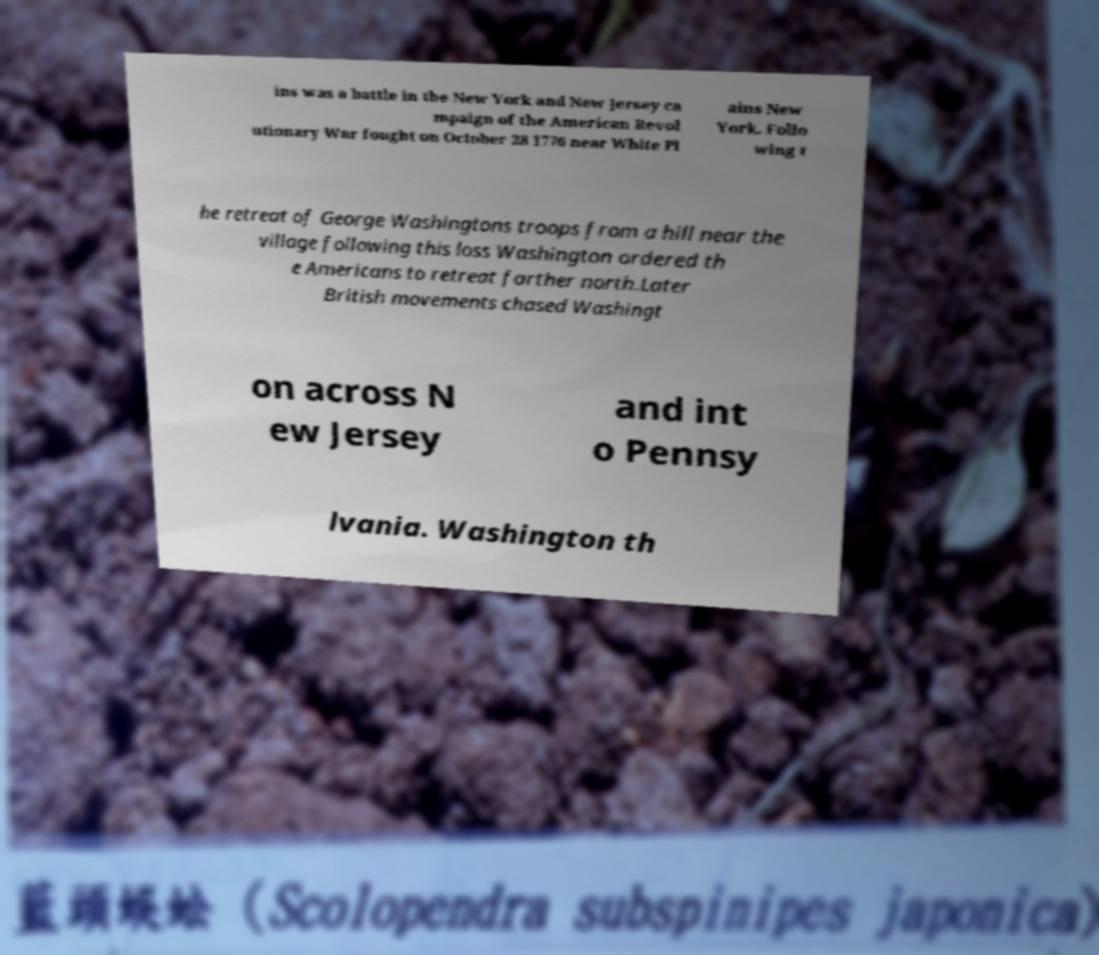Can you accurately transcribe the text from the provided image for me? ins was a battle in the New York and New Jersey ca mpaign of the American Revol utionary War fought on October 28 1776 near White Pl ains New York. Follo wing t he retreat of George Washingtons troops from a hill near the village following this loss Washington ordered th e Americans to retreat farther north.Later British movements chased Washingt on across N ew Jersey and int o Pennsy lvania. Washington th 